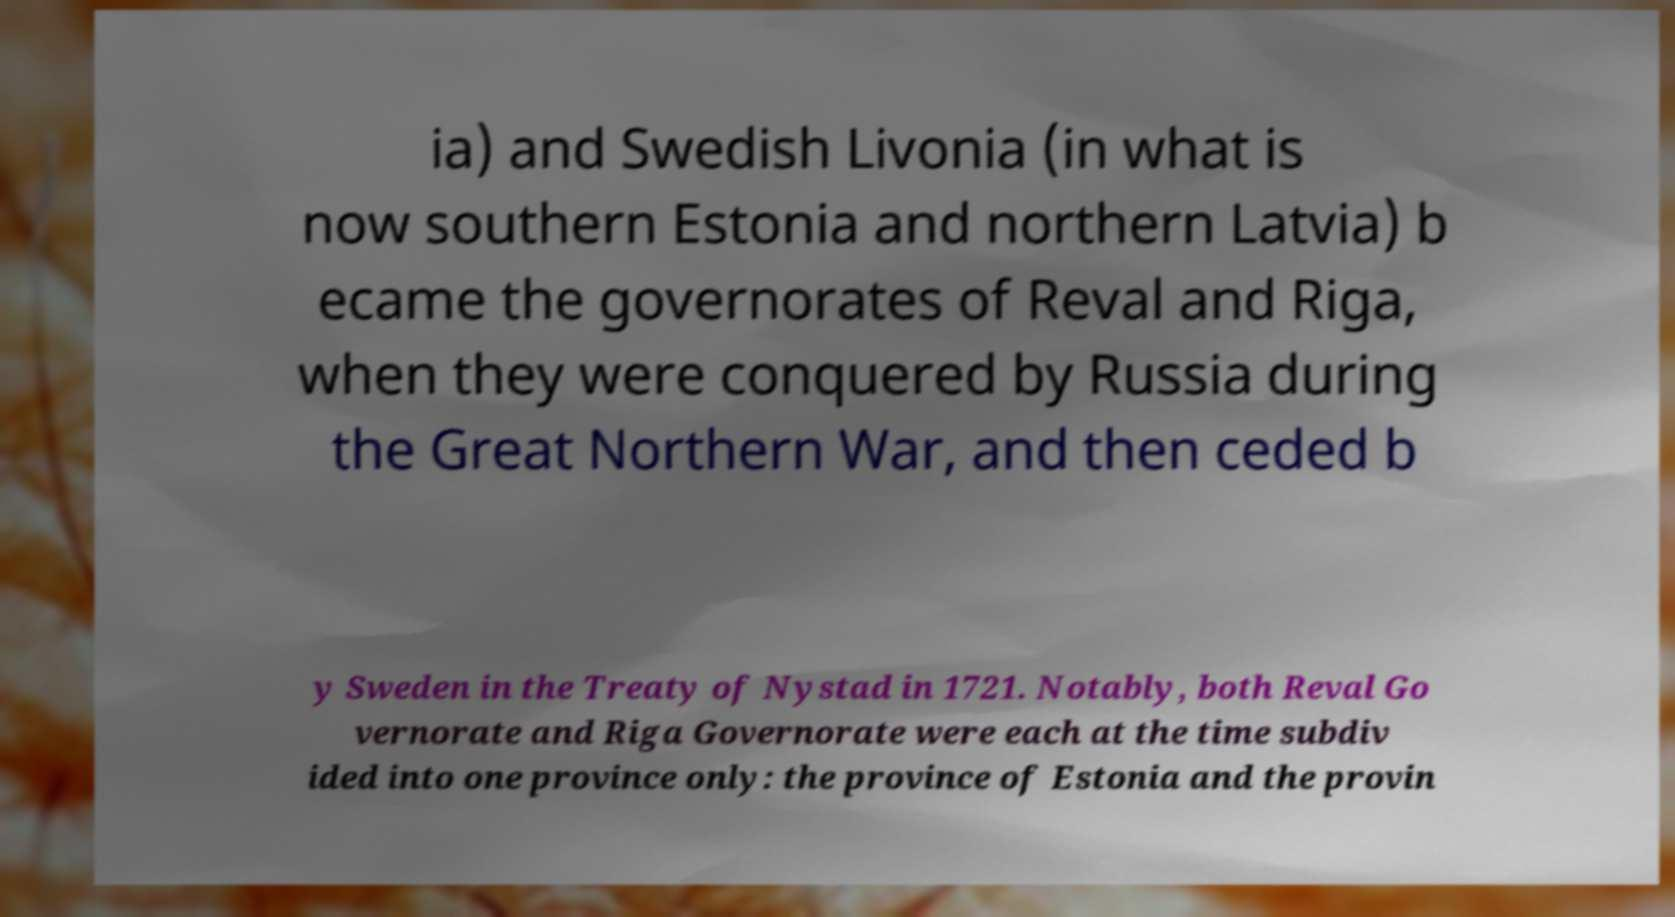I need the written content from this picture converted into text. Can you do that? ia) and Swedish Livonia (in what is now southern Estonia and northern Latvia) b ecame the governorates of Reval and Riga, when they were conquered by Russia during the Great Northern War, and then ceded b y Sweden in the Treaty of Nystad in 1721. Notably, both Reval Go vernorate and Riga Governorate were each at the time subdiv ided into one province only: the province of Estonia and the provin 